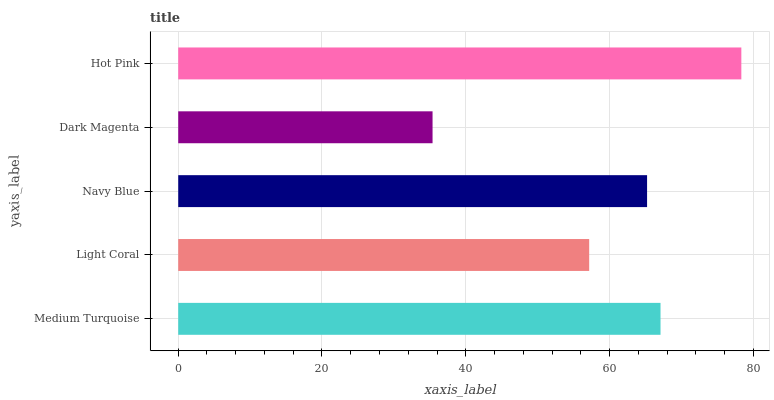Is Dark Magenta the minimum?
Answer yes or no. Yes. Is Hot Pink the maximum?
Answer yes or no. Yes. Is Light Coral the minimum?
Answer yes or no. No. Is Light Coral the maximum?
Answer yes or no. No. Is Medium Turquoise greater than Light Coral?
Answer yes or no. Yes. Is Light Coral less than Medium Turquoise?
Answer yes or no. Yes. Is Light Coral greater than Medium Turquoise?
Answer yes or no. No. Is Medium Turquoise less than Light Coral?
Answer yes or no. No. Is Navy Blue the high median?
Answer yes or no. Yes. Is Navy Blue the low median?
Answer yes or no. Yes. Is Medium Turquoise the high median?
Answer yes or no. No. Is Hot Pink the low median?
Answer yes or no. No. 